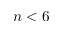Convert formula to latex. <formula><loc_0><loc_0><loc_500><loc_500>n < 6</formula> 